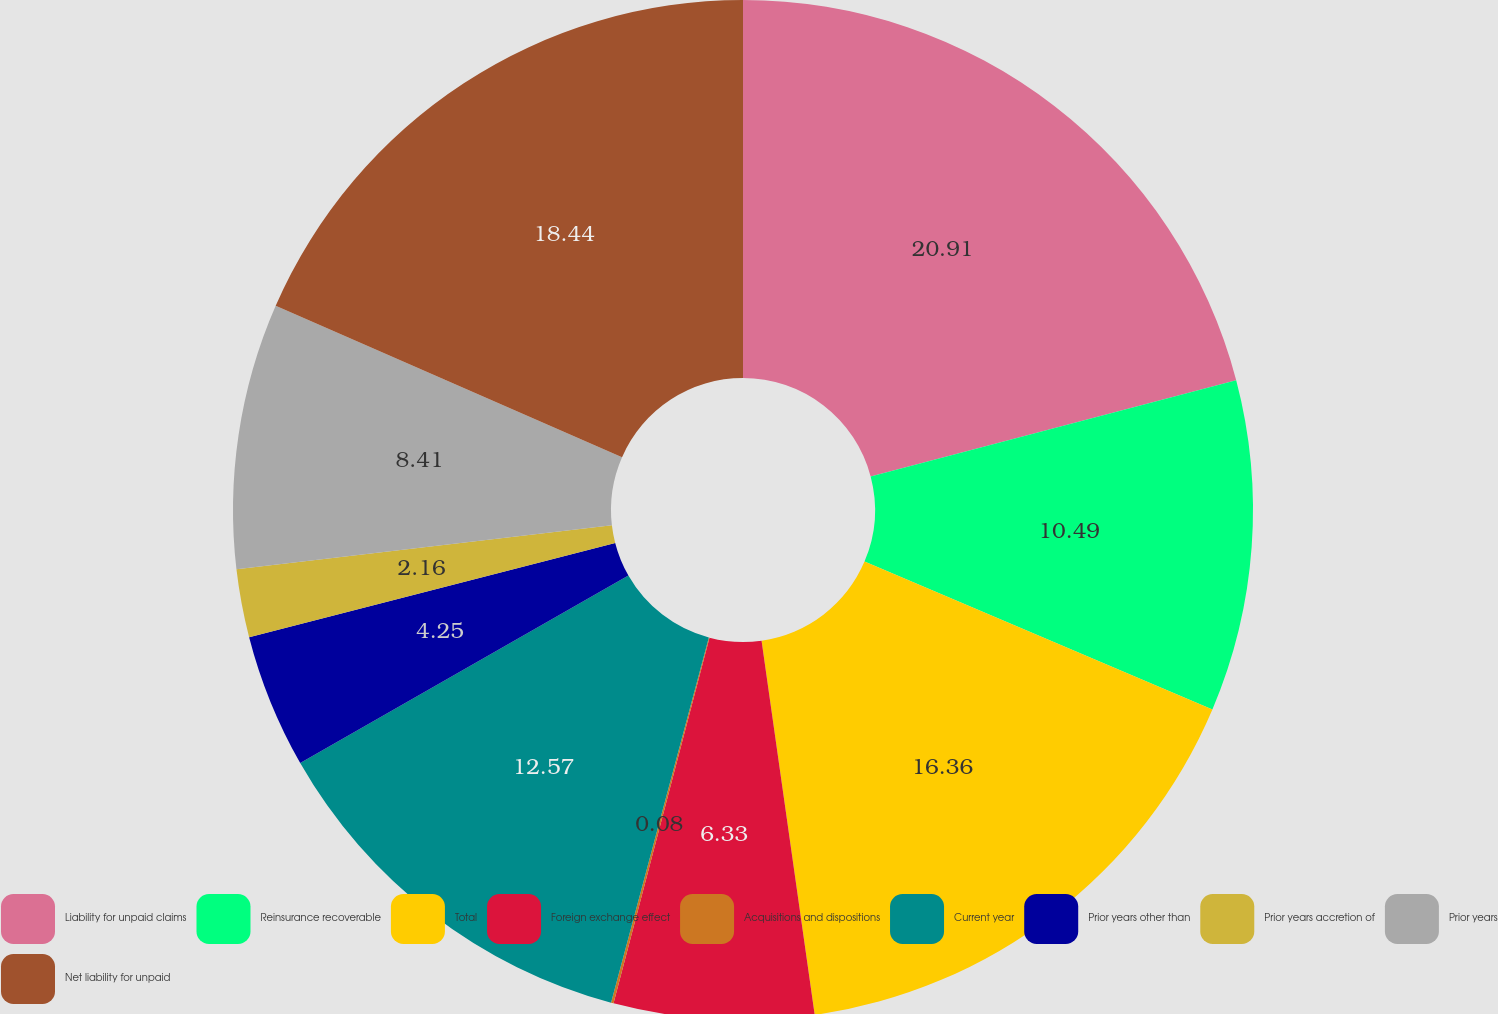<chart> <loc_0><loc_0><loc_500><loc_500><pie_chart><fcel>Liability for unpaid claims<fcel>Reinsurance recoverable<fcel>Total<fcel>Foreign exchange effect<fcel>Acquisitions and dispositions<fcel>Current year<fcel>Prior years other than<fcel>Prior years accretion of<fcel>Prior years<fcel>Net liability for unpaid<nl><fcel>20.9%<fcel>10.49%<fcel>16.36%<fcel>6.33%<fcel>0.08%<fcel>12.57%<fcel>4.25%<fcel>2.16%<fcel>8.41%<fcel>18.44%<nl></chart> 